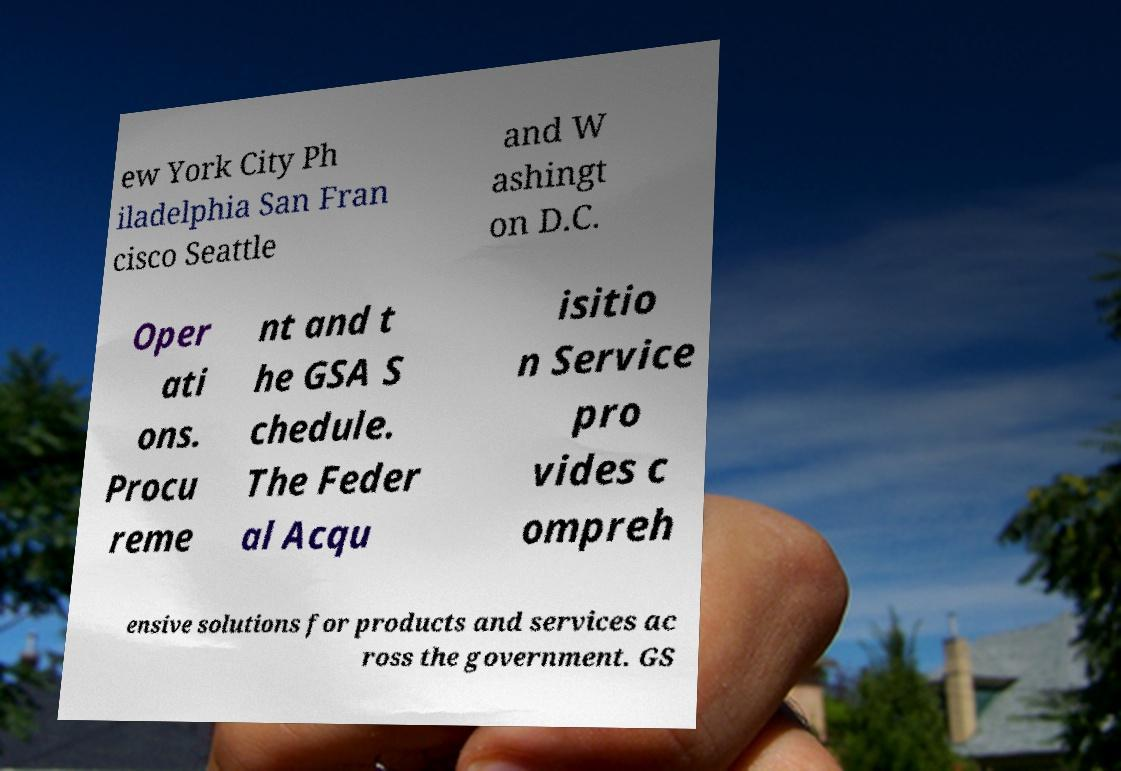Please read and relay the text visible in this image. What does it say? ew York City Ph iladelphia San Fran cisco Seattle and W ashingt on D.C. Oper ati ons. Procu reme nt and t he GSA S chedule. The Feder al Acqu isitio n Service pro vides c ompreh ensive solutions for products and services ac ross the government. GS 